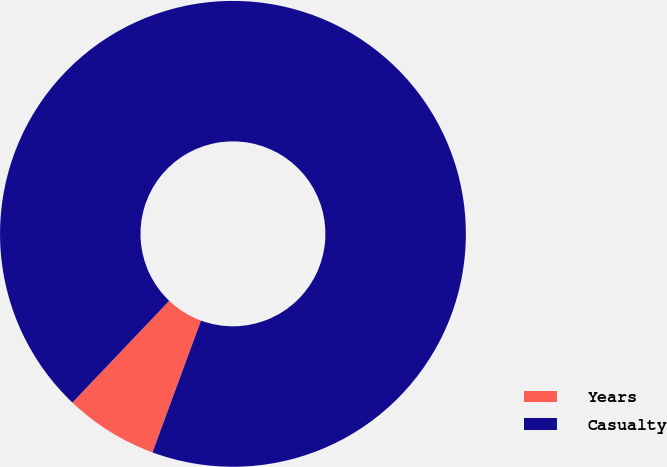<chart> <loc_0><loc_0><loc_500><loc_500><pie_chart><fcel>Years<fcel>Casualty<nl><fcel>6.49%<fcel>93.51%<nl></chart> 